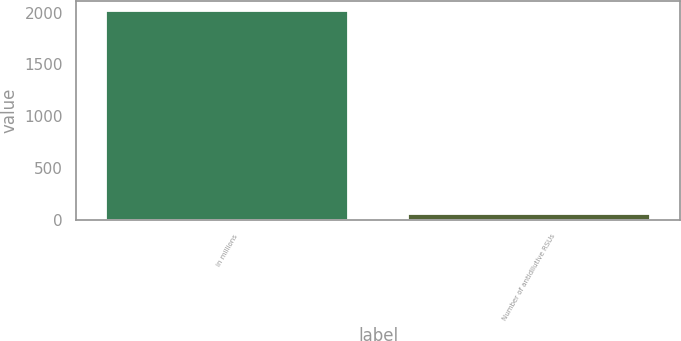Convert chart. <chart><loc_0><loc_0><loc_500><loc_500><bar_chart><fcel>in millions<fcel>Number of antidilutive RSUs<nl><fcel>2012<fcel>52.4<nl></chart> 